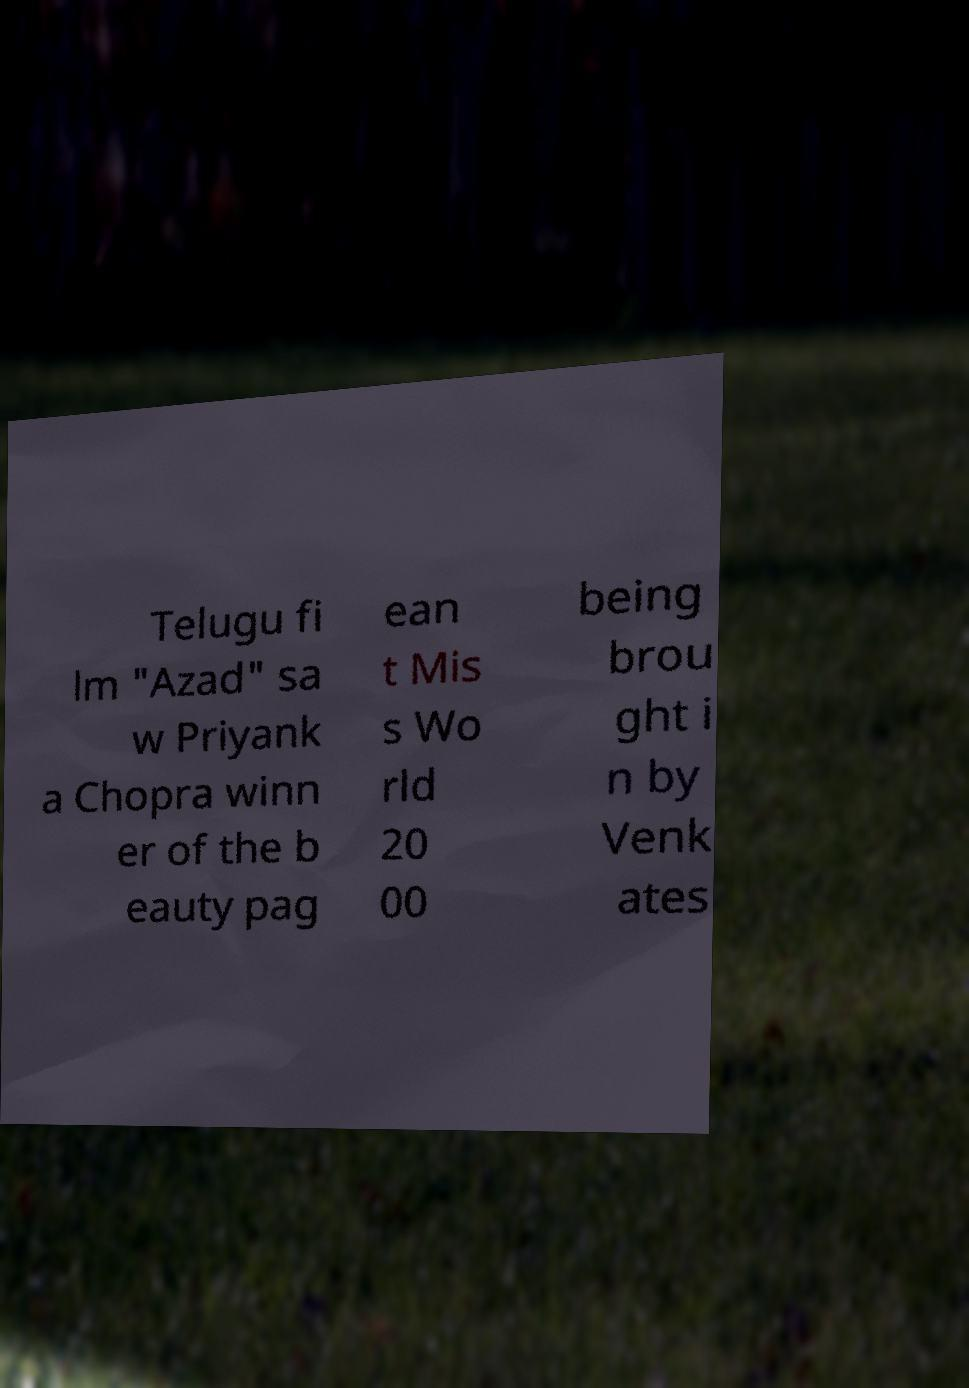Please read and relay the text visible in this image. What does it say? Telugu fi lm "Azad" sa w Priyank a Chopra winn er of the b eauty pag ean t Mis s Wo rld 20 00 being brou ght i n by Venk ates 